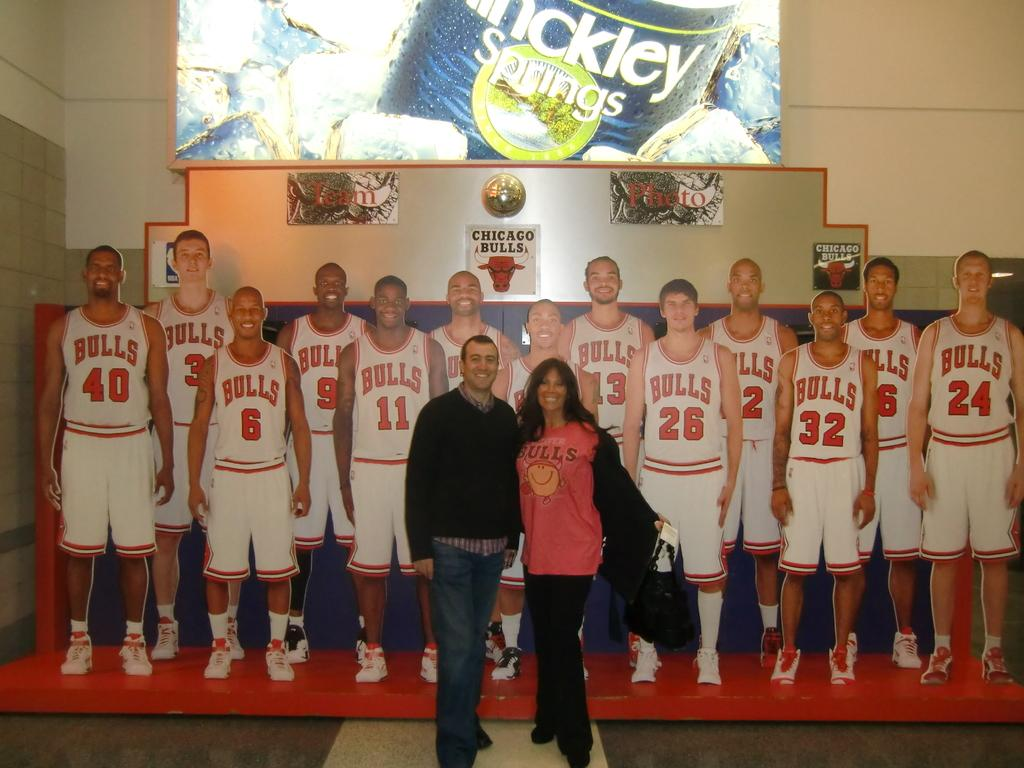<image>
Summarize the visual content of the image. The tallest player to the right wears number 24. 